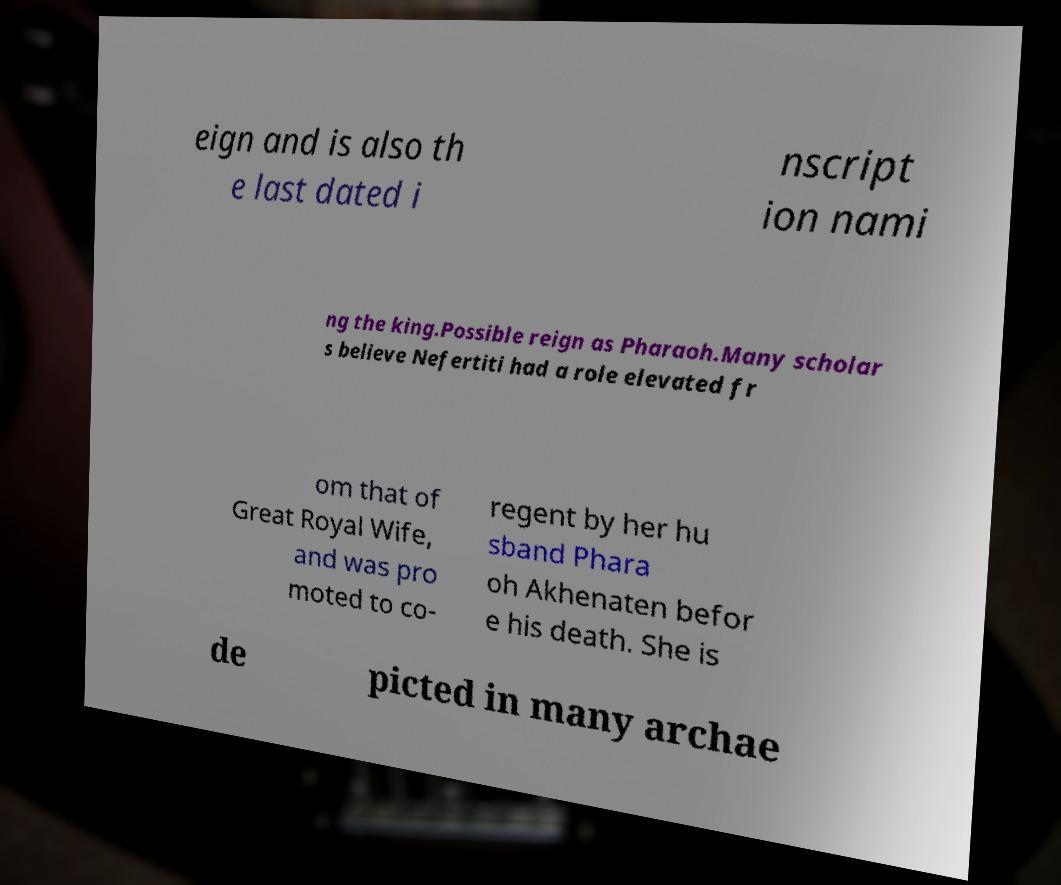Can you accurately transcribe the text from the provided image for me? eign and is also th e last dated i nscript ion nami ng the king.Possible reign as Pharaoh.Many scholar s believe Nefertiti had a role elevated fr om that of Great Royal Wife, and was pro moted to co- regent by her hu sband Phara oh Akhenaten befor e his death. She is de picted in many archae 